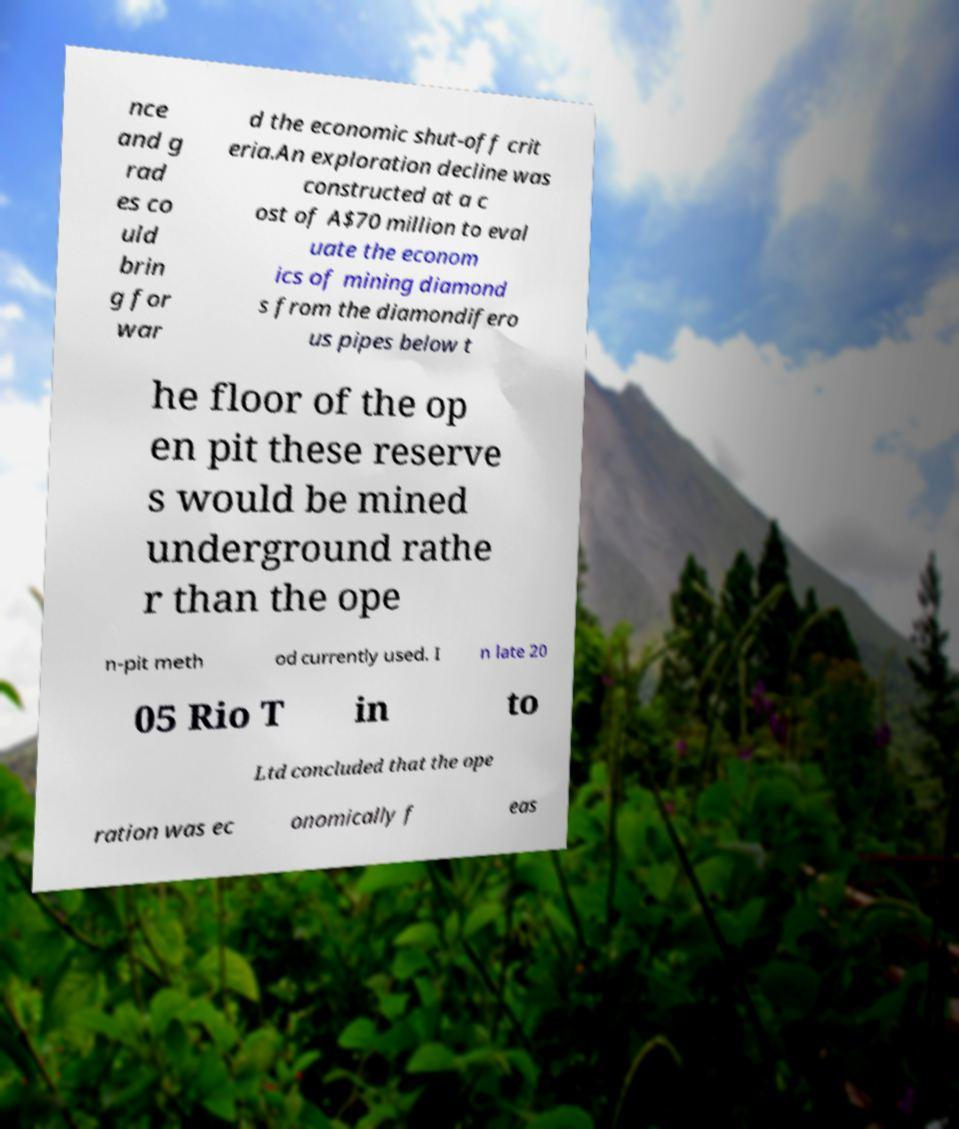Could you extract and type out the text from this image? nce and g rad es co uld brin g for war d the economic shut-off crit eria.An exploration decline was constructed at a c ost of A$70 million to eval uate the econom ics of mining diamond s from the diamondifero us pipes below t he floor of the op en pit these reserve s would be mined underground rathe r than the ope n-pit meth od currently used. I n late 20 05 Rio T in to Ltd concluded that the ope ration was ec onomically f eas 